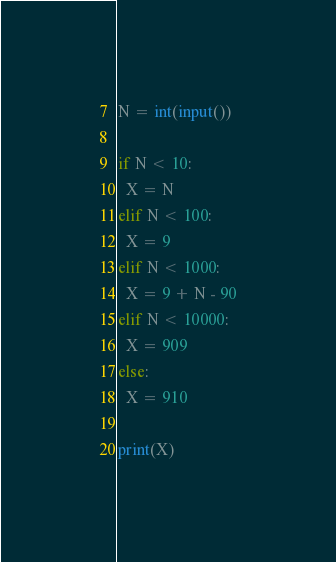Convert code to text. <code><loc_0><loc_0><loc_500><loc_500><_Python_>N = int(input())

if N < 10:
  X = N
elif N < 100:
  X = 9
elif N < 1000:
  X = 9 + N - 90
elif N < 10000:
  X = 909
else:
  X = 910

print(X)</code> 